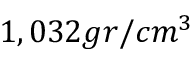<formula> <loc_0><loc_0><loc_500><loc_500>1 , 0 3 2 g r / c m ^ { 3 }</formula> 